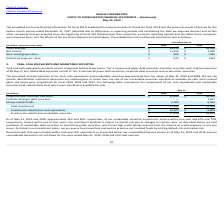According to Oracle Corporation's financial document, What do cash and cash equivalents primarily consist of? Cash and cash equivalents primarily consist of deposits held at major banks, Tier-1 commercial paper debt securities and other securities with original maturities of 90 days or less.. The document states: "Cash and cash equivalents primarily consist of deposits held at major banks, Tier-1 commercial paper debt securities and other securities with origina..." Also, Why are purchases of marketable debt securities limited to investment-grade securities? we limit purchases of marketable debt securities to investment-grade securities, which have high credit ratings and also limit the amount of credit exposure to any one issuer. As stated in our investment policy, we are averse to principal loss and seek to preserve our invested funds by limiting default risk and market risk.. The document states: "to changes in interest rates. As described above, we limit purchases of marketable debt securities to investment-grade securities, which have high cre..." Also, What was the total investment amount in 2018? According to the financial document, $52,449 (in millions). The relevant text states: "Total investments $ 27,942 $ 52,449..." Also, can you calculate: What is the amount of marketable investment securities that will mature within one year by 2020? Based on the calculation: 33%*17,313, the result is 5713.29 (in millions). This is based on the information: "Investments classified as marketable securities $ 17,313 $ 45,641 As of May 31, 2019 and 2018, approximately 33% and 26%, respectively, of our marketable securities investments mature within one year ..." The key data points involved are: 17,313, 33. Also, can you calculate: What is the investments classified as cash equivalents as a percentage of the total investments in 2019? Based on the calculation: (10,629/27,942), the result is 38.04 (percentage). This is based on the information: "Investments classified as cash equivalents $ 10,629 $ 6,808 Total investments $ 27,942 $ 52,449..." The key data points involved are: 10,629, 27,942. Also, can you calculate: What was the percentage change in the money market funds from 2018 to 2019? To answer this question, I need to perform calculations using the financial data. The calculation is: (5,700-6,500)/6,500, which equals -12.31 (percentage). This is based on the information: "Money market funds 5,700 6,500 Money market funds 5,700 6,500..." The key data points involved are: 5,700, 6,500. 